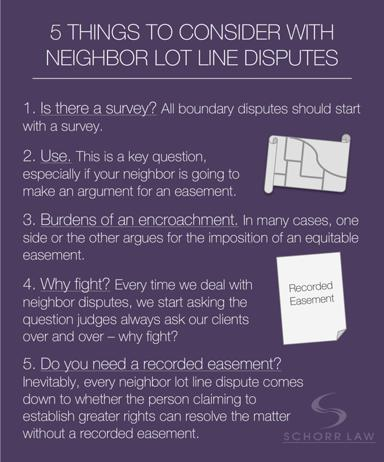What is the name of the law firm mentioned in the text? The law firm mentioned within the document is Schorr Law, which likely specializes in legal matters related to real estate and property disputes such as those involving lot lines. 